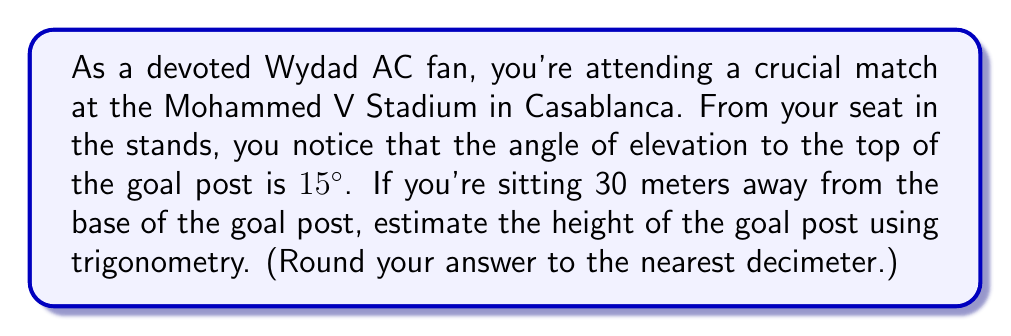Help me with this question. Let's approach this step-by-step:

1) First, let's visualize the problem:

[asy]
import geometry;

pair A = (0,0);
pair B = (30,0);
pair C = (30,8);

draw(A--B--C--A);

label("30 m", (15,0), S);
label("h", (30,4), E);
label("15°", (0,0), NW);

draw(A--(30,1.5), dashed);
draw((29,0)--(30,0)--(30,1), L);
[/asy]

2) In this right-angled triangle:
   - The adjacent side is 30 meters (distance from you to the base of the goal post)
   - The opposite side is the height of the goal post (h)
   - The angle of elevation is 15°

3) We can use the tangent function to find the height:

   $$\tan(\theta) = \frac{\text{opposite}}{\text{adjacent}}$$

4) Substituting our values:

   $$\tan(15°) = \frac{h}{30}$$

5) Rearranging to solve for h:

   $$h = 30 \tan(15°)$$

6) Now, let's calculate:
   
   $$h = 30 \times \tan(15°)$$
   $$h = 30 \times 0.26794...$$
   $$h = 8.0382... \text{ meters}$$

7) Rounding to the nearest decimeter:

   $$h \approx 8.0 \text{ meters}$$
Answer: The estimated height of the goal post is 8.0 meters. 